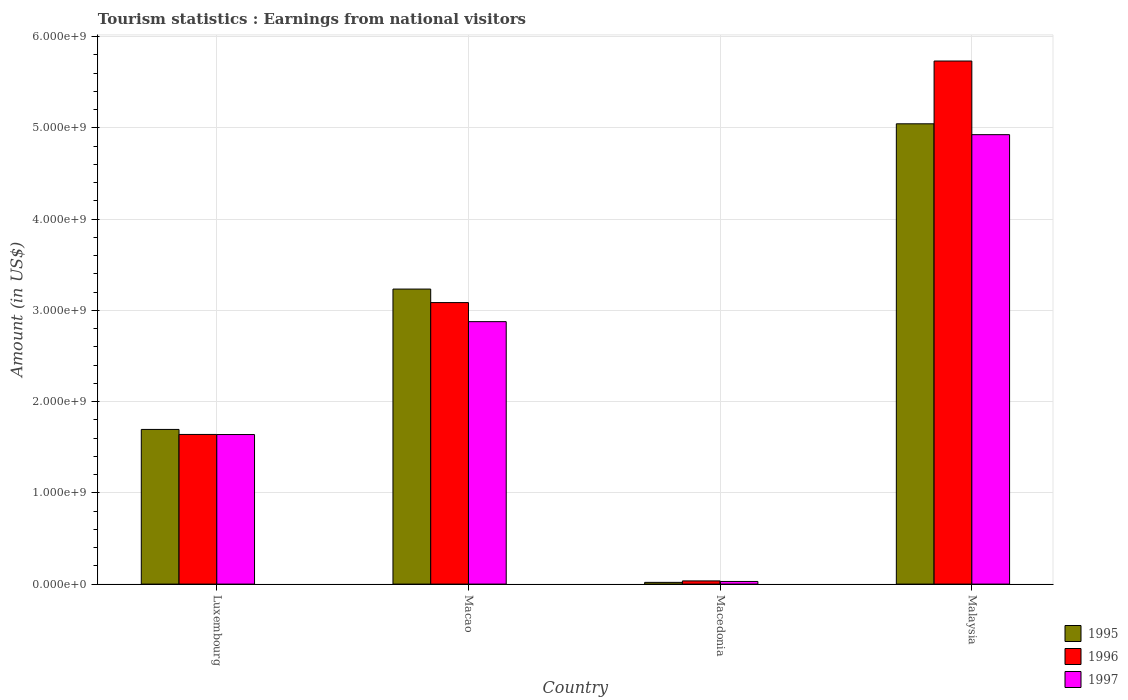Are the number of bars on each tick of the X-axis equal?
Offer a very short reply. Yes. How many bars are there on the 2nd tick from the right?
Provide a short and direct response. 3. What is the label of the 3rd group of bars from the left?
Your answer should be compact. Macedonia. What is the earnings from national visitors in 1995 in Luxembourg?
Your answer should be very brief. 1.70e+09. Across all countries, what is the maximum earnings from national visitors in 1997?
Ensure brevity in your answer.  4.92e+09. Across all countries, what is the minimum earnings from national visitors in 1995?
Make the answer very short. 1.90e+07. In which country was the earnings from national visitors in 1997 maximum?
Provide a succinct answer. Malaysia. In which country was the earnings from national visitors in 1995 minimum?
Your answer should be compact. Macedonia. What is the total earnings from national visitors in 1996 in the graph?
Provide a short and direct response. 1.05e+1. What is the difference between the earnings from national visitors in 1997 in Macedonia and that in Malaysia?
Provide a succinct answer. -4.90e+09. What is the difference between the earnings from national visitors in 1995 in Macedonia and the earnings from national visitors in 1997 in Macao?
Your answer should be compact. -2.86e+09. What is the average earnings from national visitors in 1997 per country?
Make the answer very short. 2.37e+09. What is the difference between the earnings from national visitors of/in 1996 and earnings from national visitors of/in 1997 in Macao?
Your answer should be very brief. 2.09e+08. What is the ratio of the earnings from national visitors in 1997 in Macedonia to that in Malaysia?
Provide a succinct answer. 0.01. Is the earnings from national visitors in 1996 in Macao less than that in Malaysia?
Provide a short and direct response. Yes. Is the difference between the earnings from national visitors in 1996 in Macedonia and Malaysia greater than the difference between the earnings from national visitors in 1997 in Macedonia and Malaysia?
Offer a very short reply. No. What is the difference between the highest and the second highest earnings from national visitors in 1997?
Your answer should be very brief. 2.05e+09. What is the difference between the highest and the lowest earnings from national visitors in 1996?
Offer a terse response. 5.70e+09. Are all the bars in the graph horizontal?
Provide a short and direct response. No. How many countries are there in the graph?
Keep it short and to the point. 4. What is the difference between two consecutive major ticks on the Y-axis?
Offer a terse response. 1.00e+09. Does the graph contain grids?
Provide a succinct answer. Yes. Where does the legend appear in the graph?
Your response must be concise. Bottom right. How are the legend labels stacked?
Your answer should be compact. Vertical. What is the title of the graph?
Your answer should be very brief. Tourism statistics : Earnings from national visitors. What is the Amount (in US$) in 1995 in Luxembourg?
Give a very brief answer. 1.70e+09. What is the Amount (in US$) in 1996 in Luxembourg?
Ensure brevity in your answer.  1.64e+09. What is the Amount (in US$) in 1997 in Luxembourg?
Make the answer very short. 1.64e+09. What is the Amount (in US$) in 1995 in Macao?
Give a very brief answer. 3.23e+09. What is the Amount (in US$) of 1996 in Macao?
Your response must be concise. 3.08e+09. What is the Amount (in US$) of 1997 in Macao?
Your answer should be very brief. 2.88e+09. What is the Amount (in US$) in 1995 in Macedonia?
Offer a terse response. 1.90e+07. What is the Amount (in US$) in 1996 in Macedonia?
Provide a short and direct response. 3.50e+07. What is the Amount (in US$) in 1997 in Macedonia?
Offer a very short reply. 2.90e+07. What is the Amount (in US$) of 1995 in Malaysia?
Your answer should be very brief. 5.04e+09. What is the Amount (in US$) of 1996 in Malaysia?
Your response must be concise. 5.73e+09. What is the Amount (in US$) in 1997 in Malaysia?
Offer a terse response. 4.92e+09. Across all countries, what is the maximum Amount (in US$) in 1995?
Your response must be concise. 5.04e+09. Across all countries, what is the maximum Amount (in US$) in 1996?
Your answer should be compact. 5.73e+09. Across all countries, what is the maximum Amount (in US$) in 1997?
Provide a short and direct response. 4.92e+09. Across all countries, what is the minimum Amount (in US$) of 1995?
Ensure brevity in your answer.  1.90e+07. Across all countries, what is the minimum Amount (in US$) in 1996?
Offer a very short reply. 3.50e+07. Across all countries, what is the minimum Amount (in US$) of 1997?
Provide a succinct answer. 2.90e+07. What is the total Amount (in US$) in 1995 in the graph?
Offer a terse response. 9.99e+09. What is the total Amount (in US$) in 1996 in the graph?
Make the answer very short. 1.05e+1. What is the total Amount (in US$) of 1997 in the graph?
Ensure brevity in your answer.  9.47e+09. What is the difference between the Amount (in US$) of 1995 in Luxembourg and that in Macao?
Offer a terse response. -1.54e+09. What is the difference between the Amount (in US$) in 1996 in Luxembourg and that in Macao?
Provide a short and direct response. -1.44e+09. What is the difference between the Amount (in US$) of 1997 in Luxembourg and that in Macao?
Ensure brevity in your answer.  -1.24e+09. What is the difference between the Amount (in US$) in 1995 in Luxembourg and that in Macedonia?
Keep it short and to the point. 1.68e+09. What is the difference between the Amount (in US$) of 1996 in Luxembourg and that in Macedonia?
Offer a terse response. 1.60e+09. What is the difference between the Amount (in US$) of 1997 in Luxembourg and that in Macedonia?
Offer a terse response. 1.61e+09. What is the difference between the Amount (in US$) of 1995 in Luxembourg and that in Malaysia?
Your response must be concise. -3.35e+09. What is the difference between the Amount (in US$) of 1996 in Luxembourg and that in Malaysia?
Your answer should be compact. -4.09e+09. What is the difference between the Amount (in US$) of 1997 in Luxembourg and that in Malaysia?
Provide a succinct answer. -3.29e+09. What is the difference between the Amount (in US$) of 1995 in Macao and that in Macedonia?
Offer a very short reply. 3.21e+09. What is the difference between the Amount (in US$) in 1996 in Macao and that in Macedonia?
Provide a short and direct response. 3.05e+09. What is the difference between the Amount (in US$) in 1997 in Macao and that in Macedonia?
Provide a succinct answer. 2.85e+09. What is the difference between the Amount (in US$) of 1995 in Macao and that in Malaysia?
Provide a succinct answer. -1.81e+09. What is the difference between the Amount (in US$) of 1996 in Macao and that in Malaysia?
Make the answer very short. -2.65e+09. What is the difference between the Amount (in US$) in 1997 in Macao and that in Malaysia?
Give a very brief answer. -2.05e+09. What is the difference between the Amount (in US$) of 1995 in Macedonia and that in Malaysia?
Your answer should be very brief. -5.02e+09. What is the difference between the Amount (in US$) of 1996 in Macedonia and that in Malaysia?
Your answer should be compact. -5.70e+09. What is the difference between the Amount (in US$) of 1997 in Macedonia and that in Malaysia?
Your answer should be very brief. -4.90e+09. What is the difference between the Amount (in US$) in 1995 in Luxembourg and the Amount (in US$) in 1996 in Macao?
Your response must be concise. -1.39e+09. What is the difference between the Amount (in US$) of 1995 in Luxembourg and the Amount (in US$) of 1997 in Macao?
Provide a short and direct response. -1.18e+09. What is the difference between the Amount (in US$) in 1996 in Luxembourg and the Amount (in US$) in 1997 in Macao?
Give a very brief answer. -1.24e+09. What is the difference between the Amount (in US$) in 1995 in Luxembourg and the Amount (in US$) in 1996 in Macedonia?
Give a very brief answer. 1.66e+09. What is the difference between the Amount (in US$) of 1995 in Luxembourg and the Amount (in US$) of 1997 in Macedonia?
Offer a very short reply. 1.67e+09. What is the difference between the Amount (in US$) in 1996 in Luxembourg and the Amount (in US$) in 1997 in Macedonia?
Ensure brevity in your answer.  1.61e+09. What is the difference between the Amount (in US$) of 1995 in Luxembourg and the Amount (in US$) of 1996 in Malaysia?
Give a very brief answer. -4.04e+09. What is the difference between the Amount (in US$) of 1995 in Luxembourg and the Amount (in US$) of 1997 in Malaysia?
Provide a short and direct response. -3.23e+09. What is the difference between the Amount (in US$) in 1996 in Luxembourg and the Amount (in US$) in 1997 in Malaysia?
Provide a succinct answer. -3.28e+09. What is the difference between the Amount (in US$) of 1995 in Macao and the Amount (in US$) of 1996 in Macedonia?
Make the answer very short. 3.20e+09. What is the difference between the Amount (in US$) of 1995 in Macao and the Amount (in US$) of 1997 in Macedonia?
Offer a very short reply. 3.20e+09. What is the difference between the Amount (in US$) of 1996 in Macao and the Amount (in US$) of 1997 in Macedonia?
Offer a terse response. 3.06e+09. What is the difference between the Amount (in US$) in 1995 in Macao and the Amount (in US$) in 1996 in Malaysia?
Ensure brevity in your answer.  -2.50e+09. What is the difference between the Amount (in US$) of 1995 in Macao and the Amount (in US$) of 1997 in Malaysia?
Make the answer very short. -1.69e+09. What is the difference between the Amount (in US$) of 1996 in Macao and the Amount (in US$) of 1997 in Malaysia?
Offer a terse response. -1.84e+09. What is the difference between the Amount (in US$) in 1995 in Macedonia and the Amount (in US$) in 1996 in Malaysia?
Ensure brevity in your answer.  -5.71e+09. What is the difference between the Amount (in US$) of 1995 in Macedonia and the Amount (in US$) of 1997 in Malaysia?
Give a very brief answer. -4.91e+09. What is the difference between the Amount (in US$) of 1996 in Macedonia and the Amount (in US$) of 1997 in Malaysia?
Your response must be concise. -4.89e+09. What is the average Amount (in US$) in 1995 per country?
Your answer should be compact. 2.50e+09. What is the average Amount (in US$) in 1996 per country?
Keep it short and to the point. 2.62e+09. What is the average Amount (in US$) in 1997 per country?
Your answer should be compact. 2.37e+09. What is the difference between the Amount (in US$) of 1995 and Amount (in US$) of 1996 in Luxembourg?
Provide a succinct answer. 5.50e+07. What is the difference between the Amount (in US$) in 1995 and Amount (in US$) in 1997 in Luxembourg?
Your answer should be very brief. 5.60e+07. What is the difference between the Amount (in US$) in 1995 and Amount (in US$) in 1996 in Macao?
Your response must be concise. 1.48e+08. What is the difference between the Amount (in US$) in 1995 and Amount (in US$) in 1997 in Macao?
Offer a terse response. 3.57e+08. What is the difference between the Amount (in US$) of 1996 and Amount (in US$) of 1997 in Macao?
Offer a terse response. 2.09e+08. What is the difference between the Amount (in US$) of 1995 and Amount (in US$) of 1996 in Macedonia?
Your answer should be very brief. -1.60e+07. What is the difference between the Amount (in US$) of 1995 and Amount (in US$) of 1997 in Macedonia?
Keep it short and to the point. -1.00e+07. What is the difference between the Amount (in US$) in 1995 and Amount (in US$) in 1996 in Malaysia?
Offer a very short reply. -6.88e+08. What is the difference between the Amount (in US$) in 1995 and Amount (in US$) in 1997 in Malaysia?
Your response must be concise. 1.19e+08. What is the difference between the Amount (in US$) of 1996 and Amount (in US$) of 1997 in Malaysia?
Provide a short and direct response. 8.07e+08. What is the ratio of the Amount (in US$) in 1995 in Luxembourg to that in Macao?
Provide a succinct answer. 0.52. What is the ratio of the Amount (in US$) in 1996 in Luxembourg to that in Macao?
Offer a very short reply. 0.53. What is the ratio of the Amount (in US$) in 1997 in Luxembourg to that in Macao?
Offer a very short reply. 0.57. What is the ratio of the Amount (in US$) in 1995 in Luxembourg to that in Macedonia?
Offer a very short reply. 89.21. What is the ratio of the Amount (in US$) of 1996 in Luxembourg to that in Macedonia?
Give a very brief answer. 46.86. What is the ratio of the Amount (in US$) in 1997 in Luxembourg to that in Macedonia?
Ensure brevity in your answer.  56.52. What is the ratio of the Amount (in US$) of 1995 in Luxembourg to that in Malaysia?
Ensure brevity in your answer.  0.34. What is the ratio of the Amount (in US$) in 1996 in Luxembourg to that in Malaysia?
Offer a terse response. 0.29. What is the ratio of the Amount (in US$) in 1997 in Luxembourg to that in Malaysia?
Your answer should be very brief. 0.33. What is the ratio of the Amount (in US$) in 1995 in Macao to that in Macedonia?
Offer a very short reply. 170.16. What is the ratio of the Amount (in US$) in 1996 in Macao to that in Macedonia?
Your response must be concise. 88.14. What is the ratio of the Amount (in US$) of 1997 in Macao to that in Macedonia?
Offer a very short reply. 99.17. What is the ratio of the Amount (in US$) of 1995 in Macao to that in Malaysia?
Keep it short and to the point. 0.64. What is the ratio of the Amount (in US$) in 1996 in Macao to that in Malaysia?
Give a very brief answer. 0.54. What is the ratio of the Amount (in US$) in 1997 in Macao to that in Malaysia?
Provide a succinct answer. 0.58. What is the ratio of the Amount (in US$) in 1995 in Macedonia to that in Malaysia?
Give a very brief answer. 0. What is the ratio of the Amount (in US$) of 1996 in Macedonia to that in Malaysia?
Offer a terse response. 0.01. What is the ratio of the Amount (in US$) in 1997 in Macedonia to that in Malaysia?
Give a very brief answer. 0.01. What is the difference between the highest and the second highest Amount (in US$) of 1995?
Offer a terse response. 1.81e+09. What is the difference between the highest and the second highest Amount (in US$) of 1996?
Keep it short and to the point. 2.65e+09. What is the difference between the highest and the second highest Amount (in US$) in 1997?
Offer a terse response. 2.05e+09. What is the difference between the highest and the lowest Amount (in US$) in 1995?
Keep it short and to the point. 5.02e+09. What is the difference between the highest and the lowest Amount (in US$) in 1996?
Give a very brief answer. 5.70e+09. What is the difference between the highest and the lowest Amount (in US$) of 1997?
Ensure brevity in your answer.  4.90e+09. 